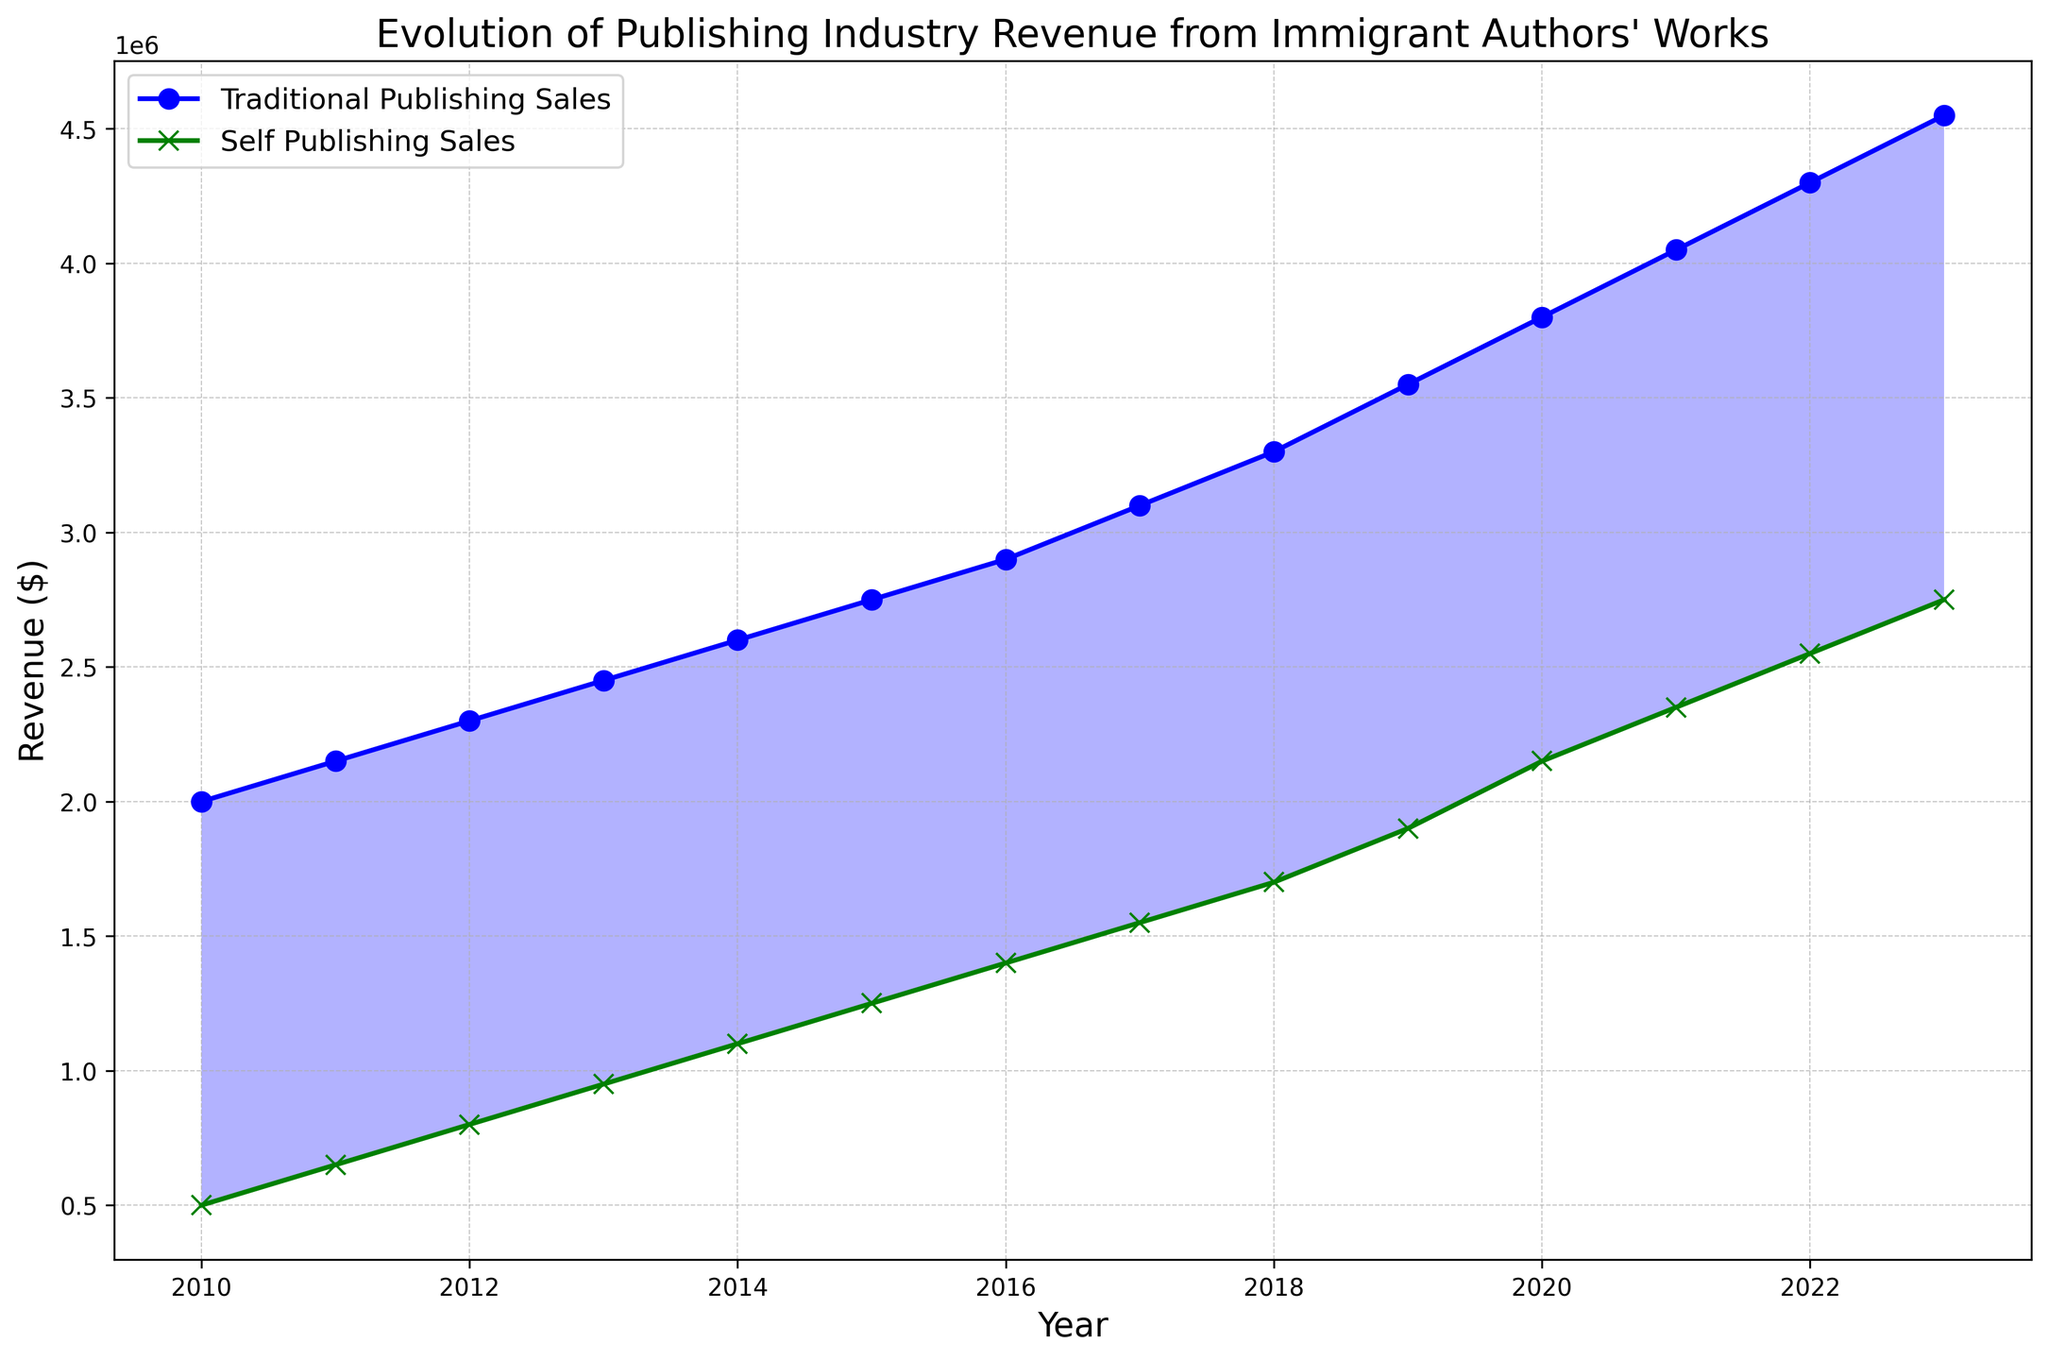What is the general trend of revenue from traditional publishing over the years? The line representing traditional publishing sales shows a consistently upward trend from 2010 to 2023, indicating increasing revenue each year.
Answer: Upward trend How does the revenue from self-publishing in 2013 compare to the revenue from traditional publishing in the same year? The plot shows that traditional publishing sales are significantly higher than self-publishing sales in 2013. The revenue from traditional publishing is $2,450,000, while self-publishing is $950,000.
Answer: Traditional publishing is higher Explain the significance of the filled areas between the two lines. The filled areas between the lines indicate the magnitude of the difference between traditional publishing sales and self-publishing sales. Blue areas show where traditional publishing sales are greater, while green areas indicate where self-publishing sales are higher.
Answer: Difference magnitude What is the average annual increase in self-publishing revenue from 2010 to 2023? To find the average annual increase, subtract the revenue of 2010 from that of 2023, then divide by the number of years: (2,750,000 - 500,000) / (2023 - 2010) = 2,250,000 / 13 ≈ 173,077.
Answer: 173,077 In which year does the revenue from self-publishing first exceed 1 million dollars? Referring to the self-publishing line, the revenue first exceeds 1 million dollars in 2014.
Answer: 2014 How much higher was traditional publishing revenue compared to self-publishing revenue in 2020? The traditional publishing revenue in 2020 is $3,800,000 and self-publishing is $2,150,000. The difference is $3,800,000 - $2,150,000 = $1,650,000.
Answer: 1,650,000 What can be said about the intersection of traditional and self-publishing revenue lines? There is no intersection between the two lines, indicating that traditional publishing revenue is always higher than self-publishing revenue in the given years.
Answer: No intersection Calculate the total revenue from traditional publishing over the period 2010-2023. Sum the traditional publishing sales from each year: 2,000,000 + 2,150,000 + 2,300,000 + 2,450,000 + 2,600,000 + 2,750,000 + 2,900,000 + 3,100,000 + 3,300,000 + 3,550,000 + 3,800,000 + 4,050,000 + 4,300,000 + 4,550,000 = 46,800,000.
Answer: 46,800,000 What is the rate of increase in revenue from traditional publishing from 2010 to 2023? Determine the rate of increase by calculating the percentage change: (4,550,000 - 2,000,000) / 2,000,000 * 100 ≈ 127.5%.
Answer: 127.5% Between 2010 and 2023, which year saw the highest annual increase in self-publishing revenue? Calculate the yearly increases for self-publishing: 2011 (150,000), 2012 (150,000), 2013 (150,000), 2014 (150,000), 2015 (150,000), 2016 (150,000), 2017 (150,000), 2018 (150,000), 2019 (200,000), 2020 (250,000), 2021 (200,000), 2022 (200,000), 2023 (200,000). The highest increase is in 2020 with $250,000.
Answer: 2020 